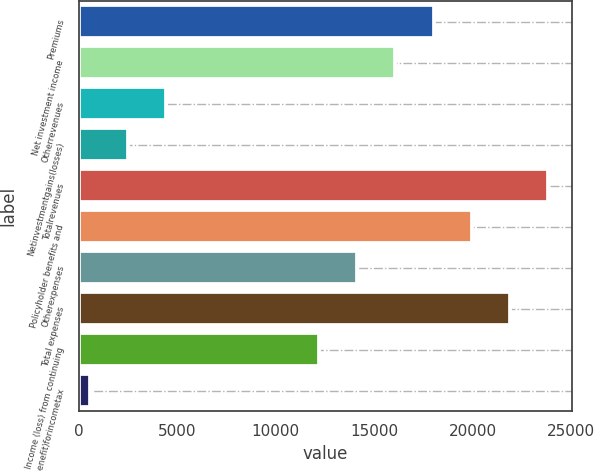Convert chart to OTSL. <chart><loc_0><loc_0><loc_500><loc_500><bar_chart><fcel>Premiums<fcel>Net investment income<fcel>Otherrevenues<fcel>Netinvestmentgains(losses)<fcel>Totalrevenues<fcel>Policyholder benefits and<fcel>Otherexpenses<fcel>Total expenses<fcel>Income (loss) from continuing<fcel>Provision(benefit)forincometax<nl><fcel>18016.7<fcel>16077.4<fcel>4441.6<fcel>2502.3<fcel>23834.6<fcel>19956<fcel>14138.1<fcel>21895.3<fcel>12198.8<fcel>563<nl></chart> 